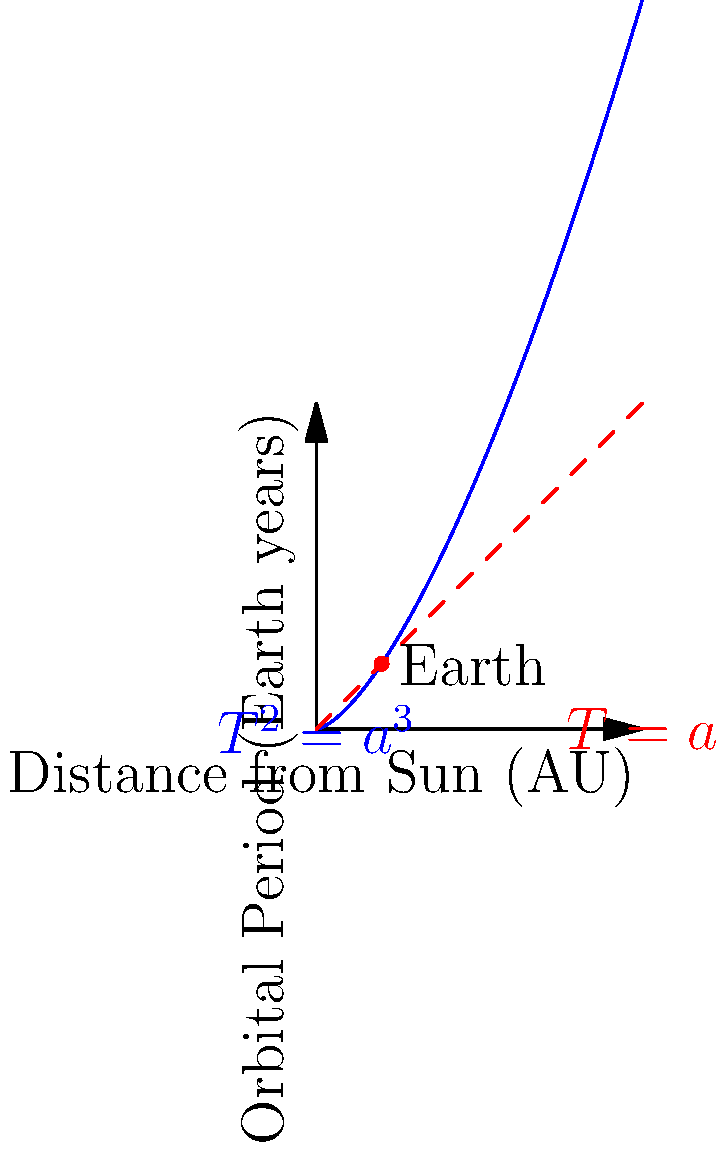You've just received a challenging support ticket! A curious astronomer wants to calculate the orbital period of an exoplanet that's 3.375 AU from its star (assume the star has the same mass as our Sun). Using Kepler's Third Law, how quickly can you determine the orbital period of this planet in Earth years? Let's tackle this challenge step-by-step:

1) Kepler's Third Law states that the square of the orbital period of a planet is directly proportional to the cube of the semi-major axis of its orbit. For circular orbits, this is simplified to:

   $$T^2 = a^3$$

   Where $T$ is the orbital period in Earth years and $a$ is the distance from the Sun in Astronomical Units (AU).

2) We're given that $a = 3.375$ AU.

3) Substituting this into the equation:

   $$T^2 = 3.375^3$$

4) Calculate the right side:
   
   $$T^2 = 38.443359375$$

5) To find $T$, we need to take the square root of both sides:

   $$T = \sqrt{38.443359375}$$

6) Calculate the square root:

   $$T \approx 6.2$$

Therefore, the orbital period of the exoplanet is approximately 6.2 Earth years.
Answer: 6.2 Earth years 